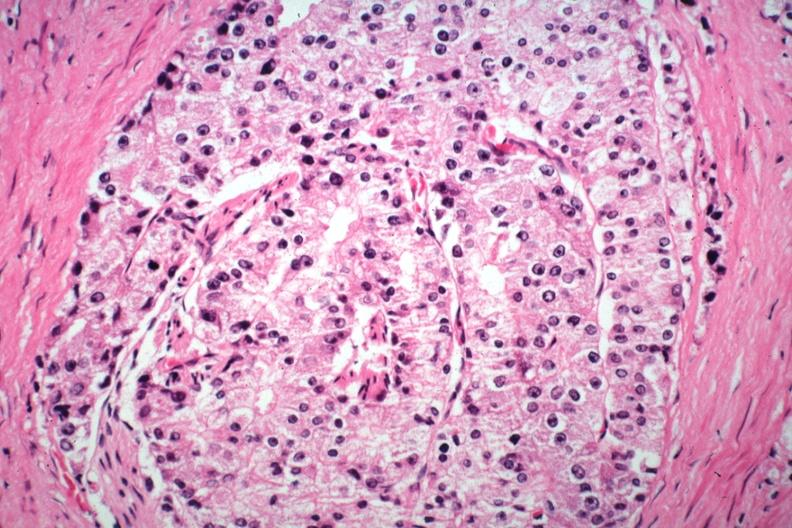does this image show typical histology and cytology of this lesion?
Answer the question using a single word or phrase. Yes 